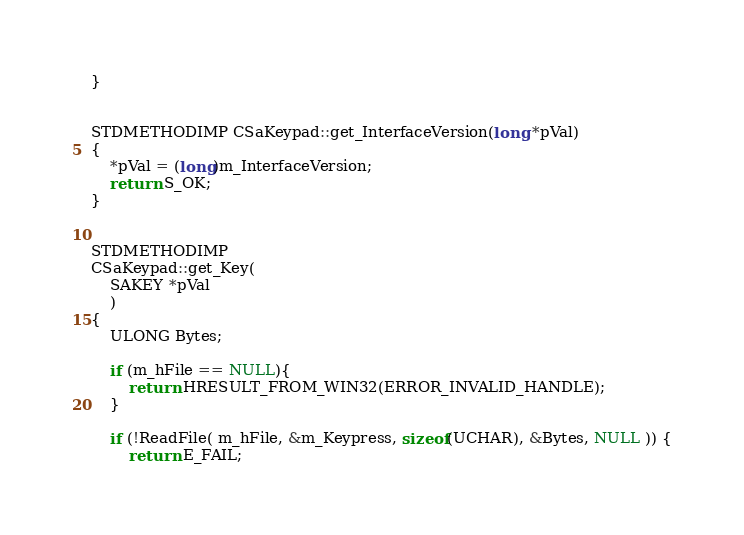Convert code to text. <code><loc_0><loc_0><loc_500><loc_500><_C++_>}


STDMETHODIMP CSaKeypad::get_InterfaceVersion(long *pVal)
{
    *pVal = (long)m_InterfaceVersion;
    return S_OK;
}


STDMETHODIMP
CSaKeypad::get_Key(
    SAKEY *pVal
    )
{
    ULONG Bytes;

    if (m_hFile == NULL){
        return HRESULT_FROM_WIN32(ERROR_INVALID_HANDLE);
    }

    if (!ReadFile( m_hFile, &m_Keypress, sizeof(UCHAR), &Bytes, NULL )) {
        return E_FAIL;</code> 